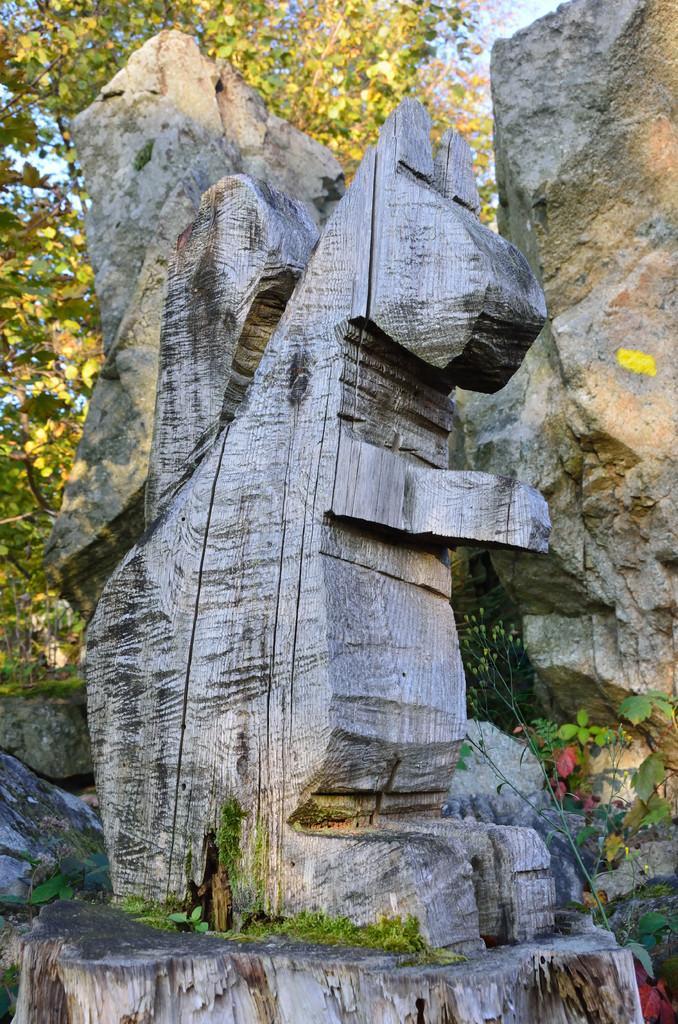Could you give a brief overview of what you see in this image? In this image there is a wooden statue which is carved on the tree. In the background there are stones. Behind the stones there are trees. 